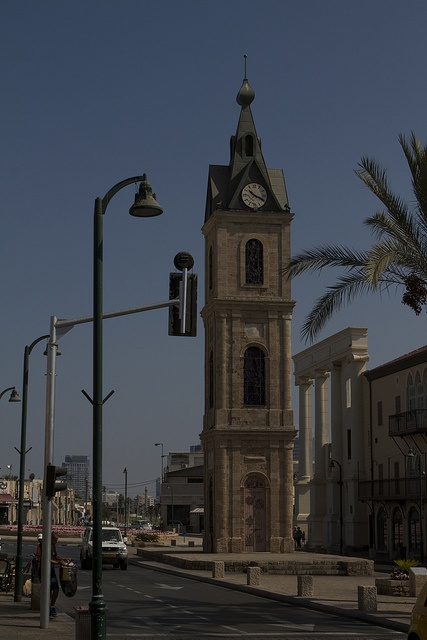Describe the objects in this image and their specific colors. I can see car in darkblue, black, gray, and darkgray tones, traffic light in darkblue, black, and gray tones, clock in darkblue, gray, and black tones, traffic light in darkblue, black, and gray tones, and people in darkblue, black, gray, and maroon tones in this image. 